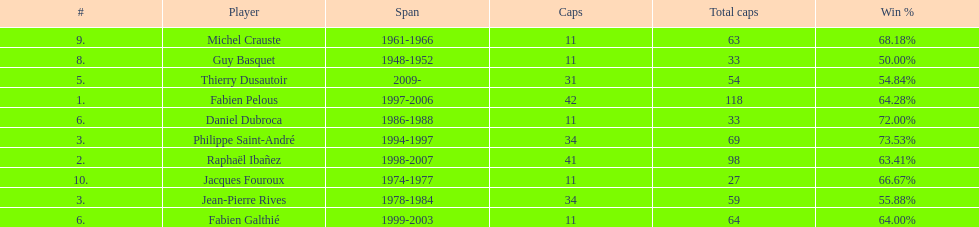Which player has the highest win percentage? Philippe Saint-André. 